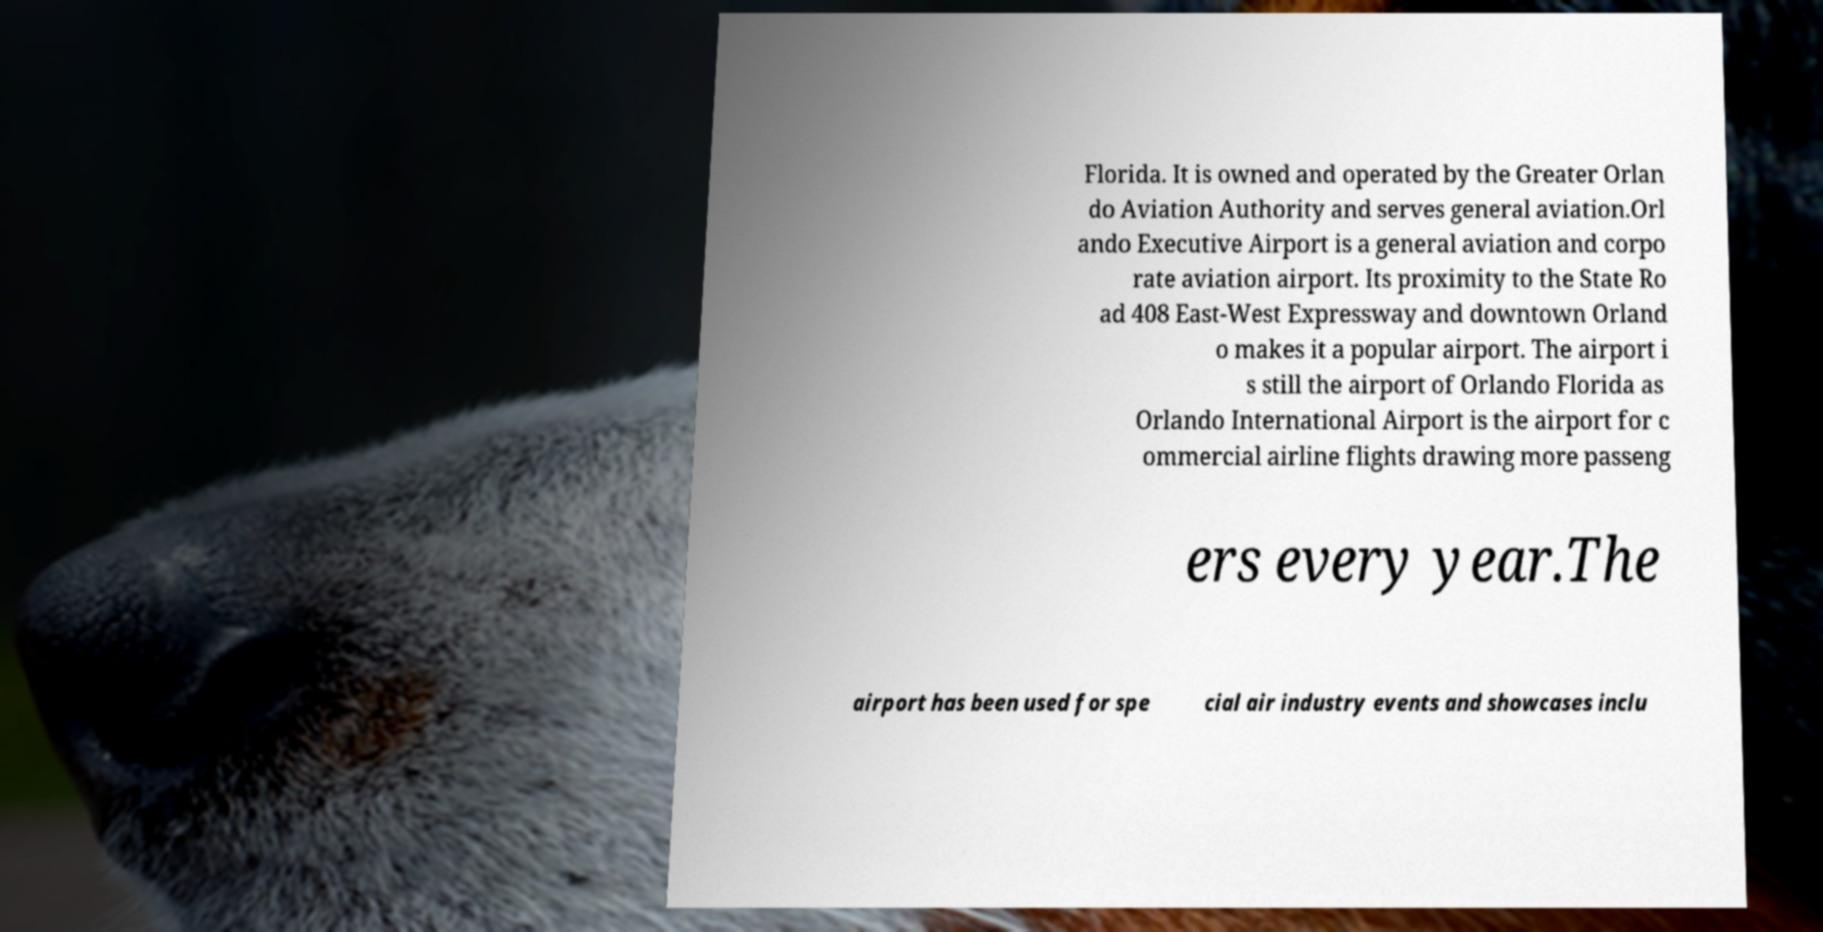There's text embedded in this image that I need extracted. Can you transcribe it verbatim? Florida. It is owned and operated by the Greater Orlan do Aviation Authority and serves general aviation.Orl ando Executive Airport is a general aviation and corpo rate aviation airport. Its proximity to the State Ro ad 408 East-West Expressway and downtown Orland o makes it a popular airport. The airport i s still the airport of Orlando Florida as Orlando International Airport is the airport for c ommercial airline flights drawing more passeng ers every year.The airport has been used for spe cial air industry events and showcases inclu 